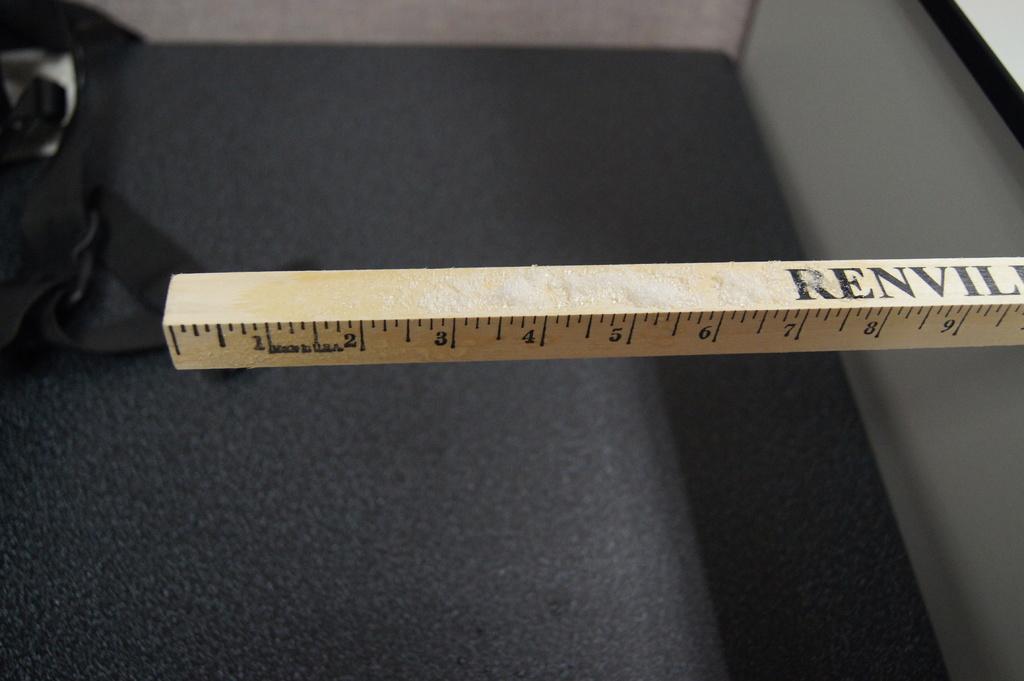Where was this ruler made?
Provide a succinct answer. Usa. What is one of the numbers on the ruler?
Provide a succinct answer. 1. 